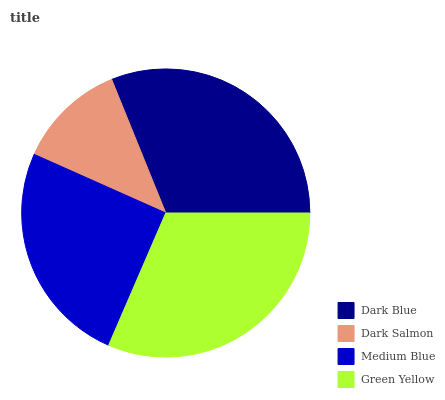Is Dark Salmon the minimum?
Answer yes or no. Yes. Is Green Yellow the maximum?
Answer yes or no. Yes. Is Medium Blue the minimum?
Answer yes or no. No. Is Medium Blue the maximum?
Answer yes or no. No. Is Medium Blue greater than Dark Salmon?
Answer yes or no. Yes. Is Dark Salmon less than Medium Blue?
Answer yes or no. Yes. Is Dark Salmon greater than Medium Blue?
Answer yes or no. No. Is Medium Blue less than Dark Salmon?
Answer yes or no. No. Is Dark Blue the high median?
Answer yes or no. Yes. Is Medium Blue the low median?
Answer yes or no. Yes. Is Green Yellow the high median?
Answer yes or no. No. Is Dark Salmon the low median?
Answer yes or no. No. 